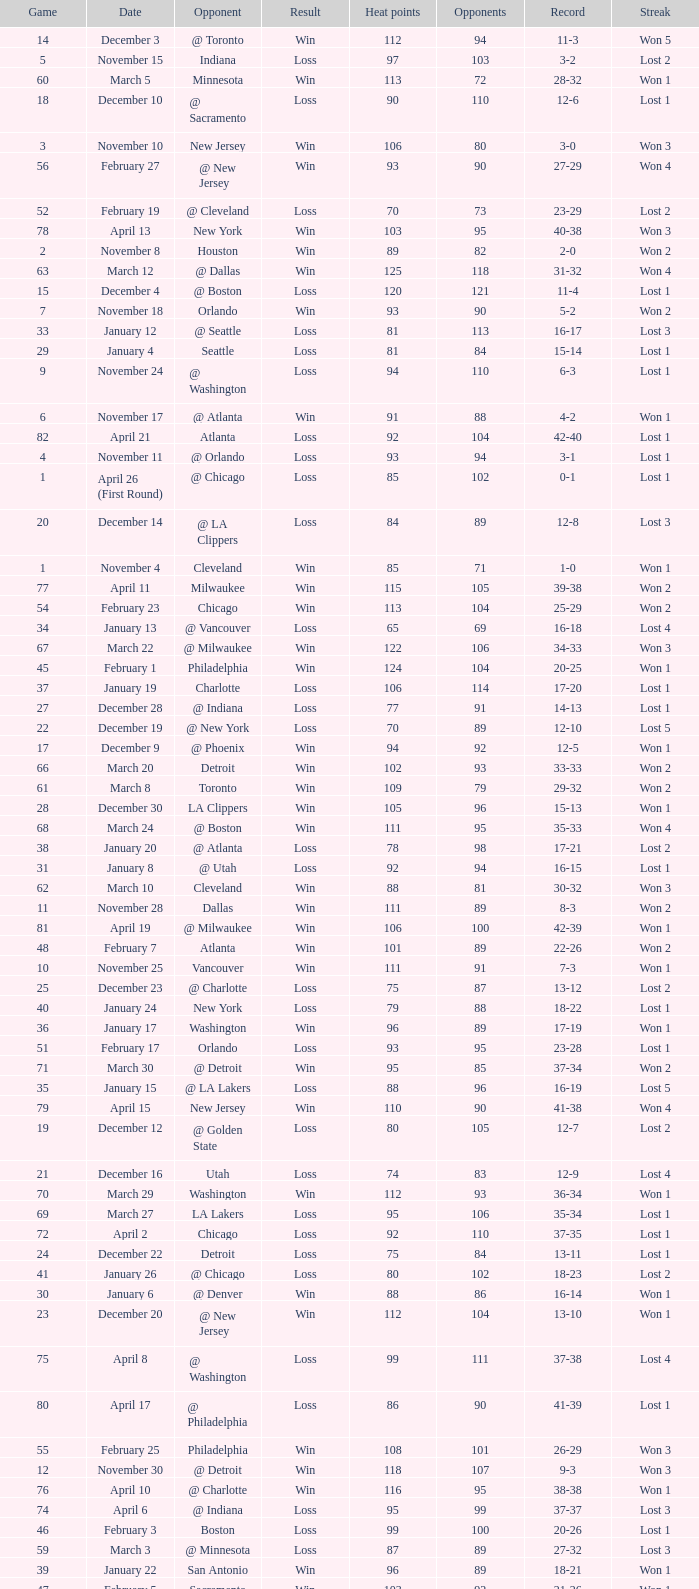What is the average Heat Points, when Result is "Loss", when Game is greater than 72, and when Date is "April 21"? 92.0. 